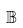Convert formula to latex. <formula><loc_0><loc_0><loc_500><loc_500>\mathbb { B }</formula> 